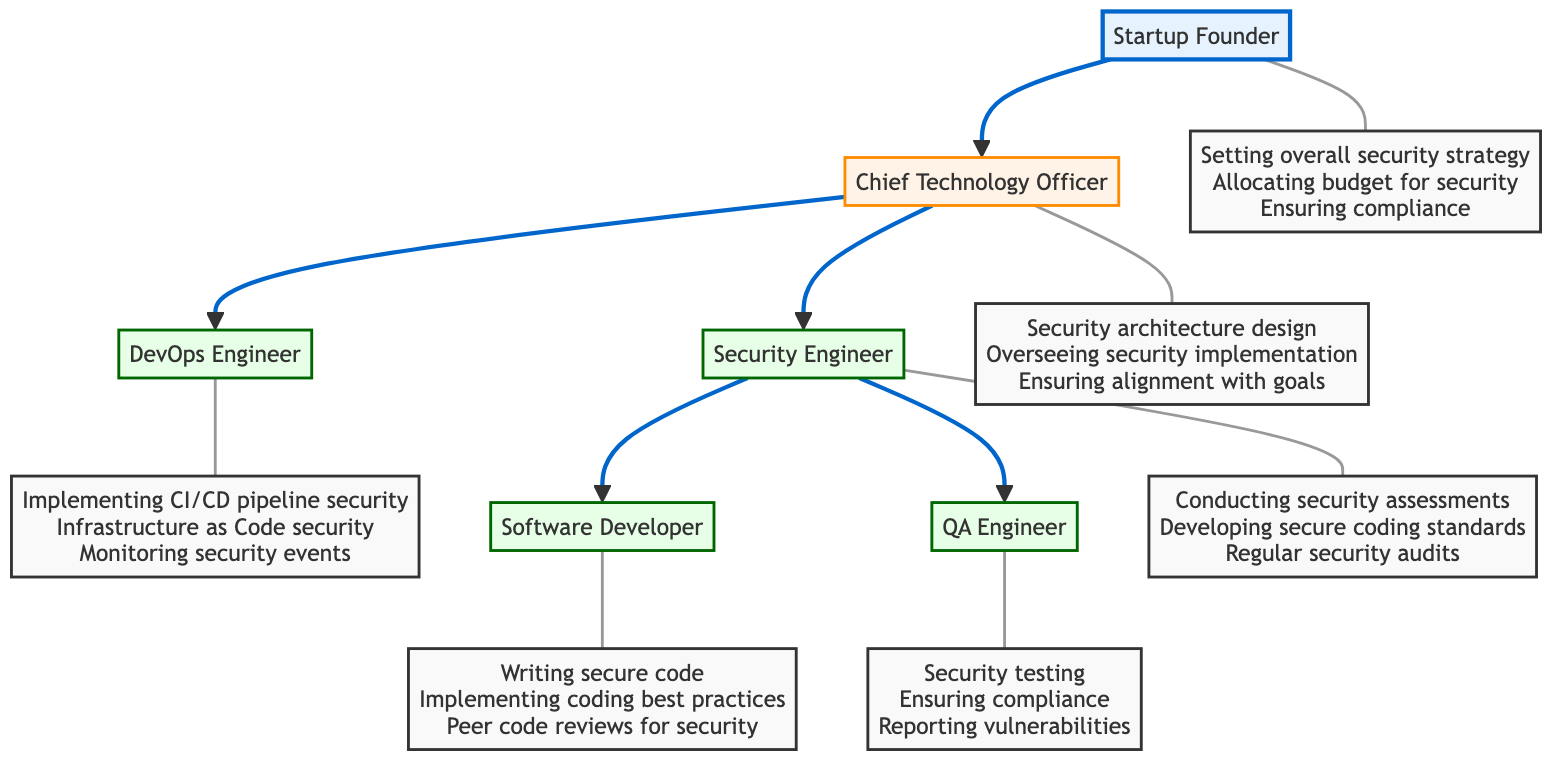What is the highest position in the serverless application team? The highest position in the diagram is denoted by the top node, which is the "Startup Founder." This node has no other nodes reporting to it, indicating it is at the top of the hierarchy.
Answer: Startup Founder How many roles are there in total within the serverless application team? By counting each listed role in the diagram, we find there are six distinct roles: Startup Founder, Chief Technology Officer, DevOps Engineer, Security Engineer, Software Developer, and QA Engineer. Therefore, the total is six.
Answer: 6 Who reports directly to the Chief Technology Officer? According to the diagram, the DevOps Engineer and the Security Engineer are the roles that report directly to the Chief Technology Officer, as they are connected with a directed line originating from the CTO node.
Answer: DevOps Engineer, Security Engineer What responsibility is assigned to the Security Engineer? The "Conducting security assessments" is one of the stated responsibilities for the Security Engineer. This can be found as a specific responsibility directly linked to the Security Engineer node in the diagram.
Answer: Conducting security assessments How many responsibilities does the QA Engineer have? The QA Engineer is listed with three specific responsibilities in the diagram: Security testing, Ensuring compliance with security requirements, and Reporting security vulnerabilities. The count of these responsibilities adds up to three.
Answer: 3 Which role has the responsibility of writing secure code? The responsibility of "Writing secure code" is explicitly assigned to the Software Developer, a role that is clearly shown reporting to the Security Engineer in the diagram.
Answer: Software Developer What is the primary reporting relationship indicated in the diagram between the Startup Founder and the CTO? The diagram clearly indicates a direct reporting line from the Startup Founder to the Chief Technology Officer (CTO), illustrated by a directed edge going from the Founder node to the CTO node.
Answer: CTO Which role is responsible for ensuring compliance with security requirements? The "Ensuring compliance with security requirements" is a specific responsibility of the QA Engineer, as this responsibility is linked to the QA role in the diagram.
Answer: QA Engineer What role is primarily accountable for security architecture design? The "Chief Technology Officer" is responsible for the security architecture design. This role is depicted in the diagram, with the corresponding responsibility clearly listed as part of its assigned tasks.
Answer: Chief Technology Officer 